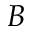Convert formula to latex. <formula><loc_0><loc_0><loc_500><loc_500>B</formula> 